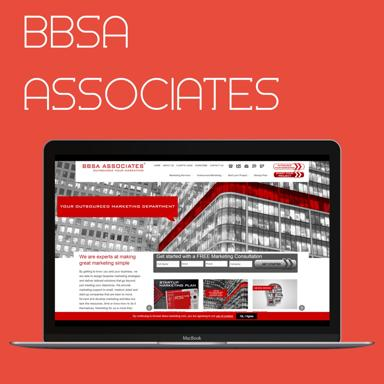What is the company name mentioned on the laptop? The company name mentioned on the laptop is BBSA Associates. 